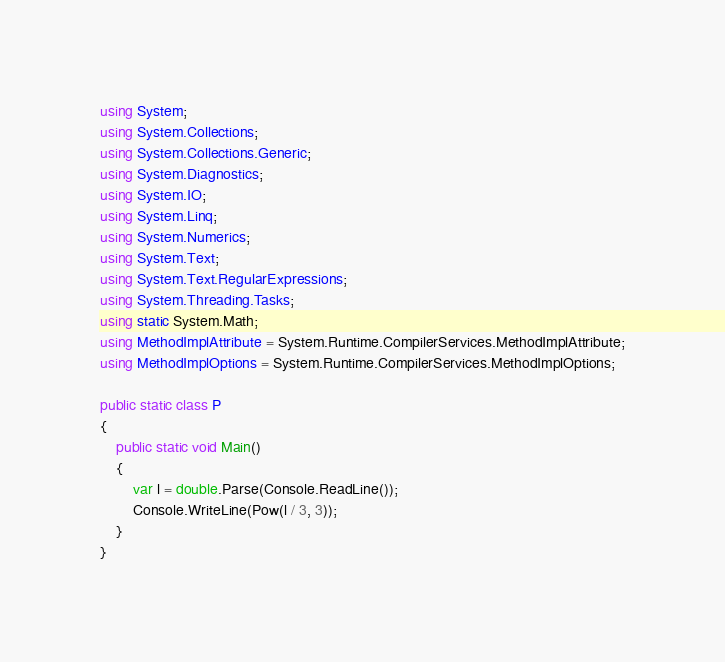Convert code to text. <code><loc_0><loc_0><loc_500><loc_500><_C#_>using System;
using System.Collections;
using System.Collections.Generic;
using System.Diagnostics;
using System.IO;
using System.Linq;
using System.Numerics;
using System.Text;
using System.Text.RegularExpressions;
using System.Threading.Tasks;
using static System.Math;
using MethodImplAttribute = System.Runtime.CompilerServices.MethodImplAttribute;
using MethodImplOptions = System.Runtime.CompilerServices.MethodImplOptions;

public static class P
{
    public static void Main()
    {
        var l = double.Parse(Console.ReadLine());
        Console.WriteLine(Pow(l / 3, 3));
    }
}
</code> 